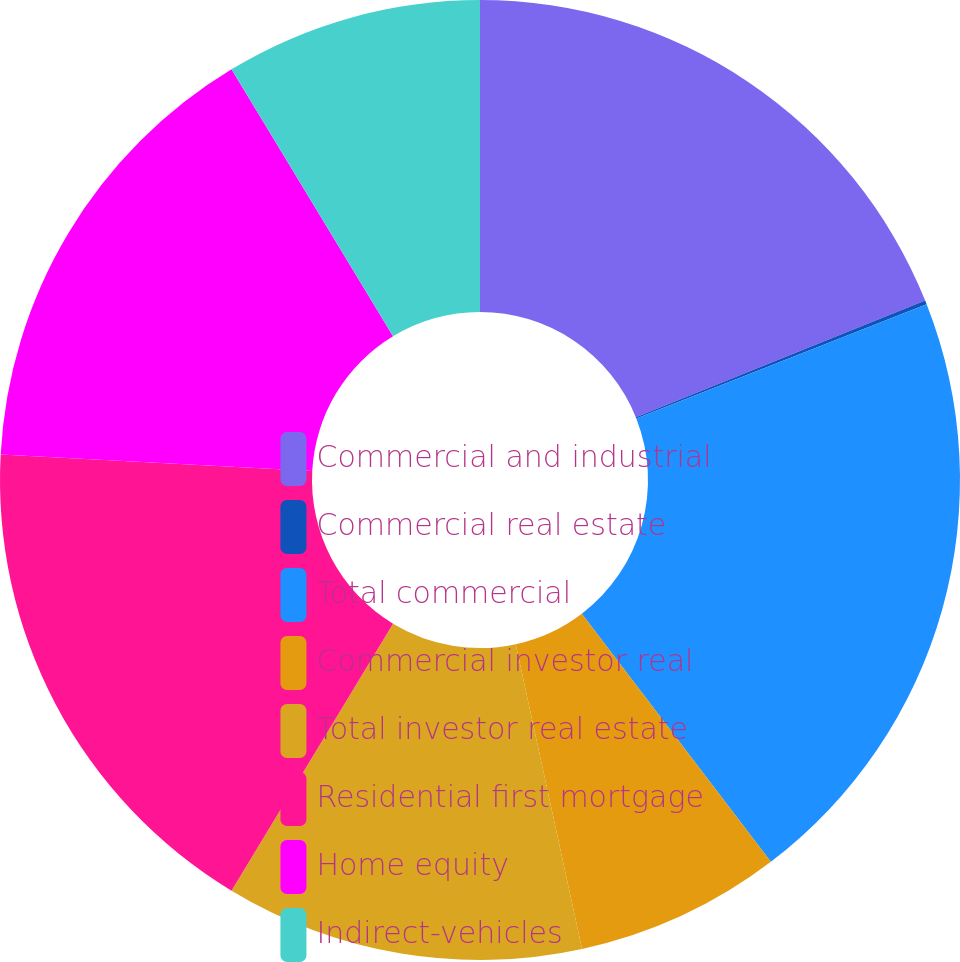Convert chart to OTSL. <chart><loc_0><loc_0><loc_500><loc_500><pie_chart><fcel>Commercial and industrial<fcel>Commercial real estate<fcel>Total commercial<fcel>Commercial investor real<fcel>Total investor real estate<fcel>Residential first mortgage<fcel>Home equity<fcel>Indirect-vehicles<nl><fcel>18.9%<fcel>0.13%<fcel>20.61%<fcel>6.95%<fcel>12.07%<fcel>17.19%<fcel>15.49%<fcel>8.66%<nl></chart> 